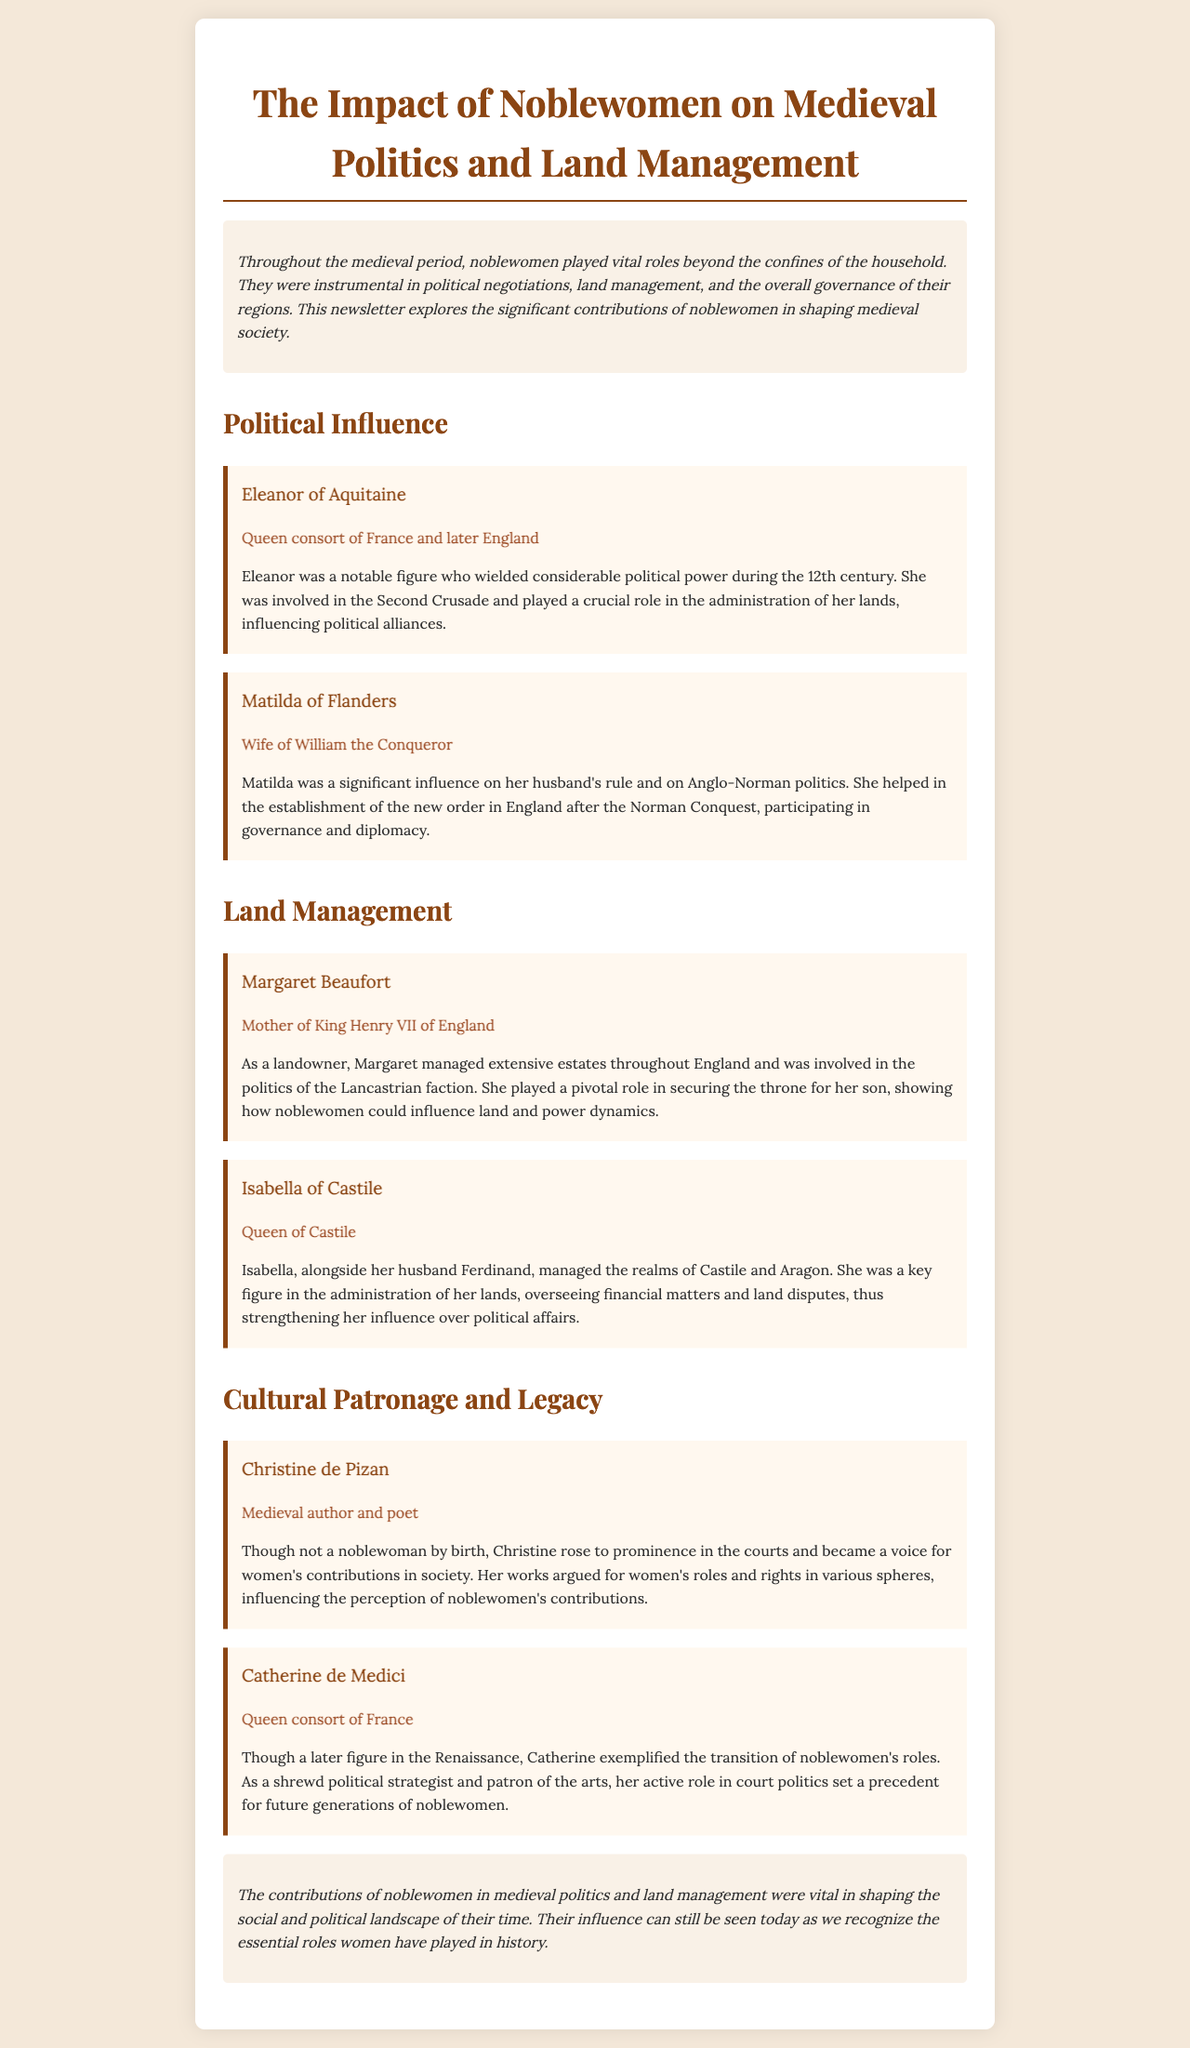What title did Eleanor of Aquitaine hold? Eleanor of Aquitaine was the Queen consort of France and later England, which is noted in the document.
Answer: Queen consort of France and later England Who was the wife of William the Conqueror? The document states that Matilda of Flanders was the wife of William the Conqueror.
Answer: Matilda of Flanders Which noblewoman was the mother of King Henry VII? The document identifies Margaret Beaufort as the mother of King Henry VII of England.
Answer: Margaret Beaufort What role did Isabella of Castile hold? The document mentions that Isabella was the Queen of Castile.
Answer: Queen of Castile How did Christine de Pizan contribute to society? The newsletter explains that Christine de Pizan rose to prominence in the courts and became a voice for women's contributions in society.
Answer: Medieval author and poet What political strategy is Catherine de Medici known for? According to the document, Catherine de Medici is noted for being a shrewd political strategist.
Answer: Shrewd political strategist In which century did Eleanor of Aquitaine have political influence? The document indicates that Eleanor wielded considerable political power during the 12th century.
Answer: 12th century What major event did Eleanor of Aquitaine participate in? The newsletter states that Eleanor was involved in the Second Crusade.
Answer: Second Crusade What does the conclusion of the document emphasize about noblewomen? The conclusion highlights that noblewomen's contributions were vital in shaping the social and political landscape of their time.
Answer: Vital contributions to society 